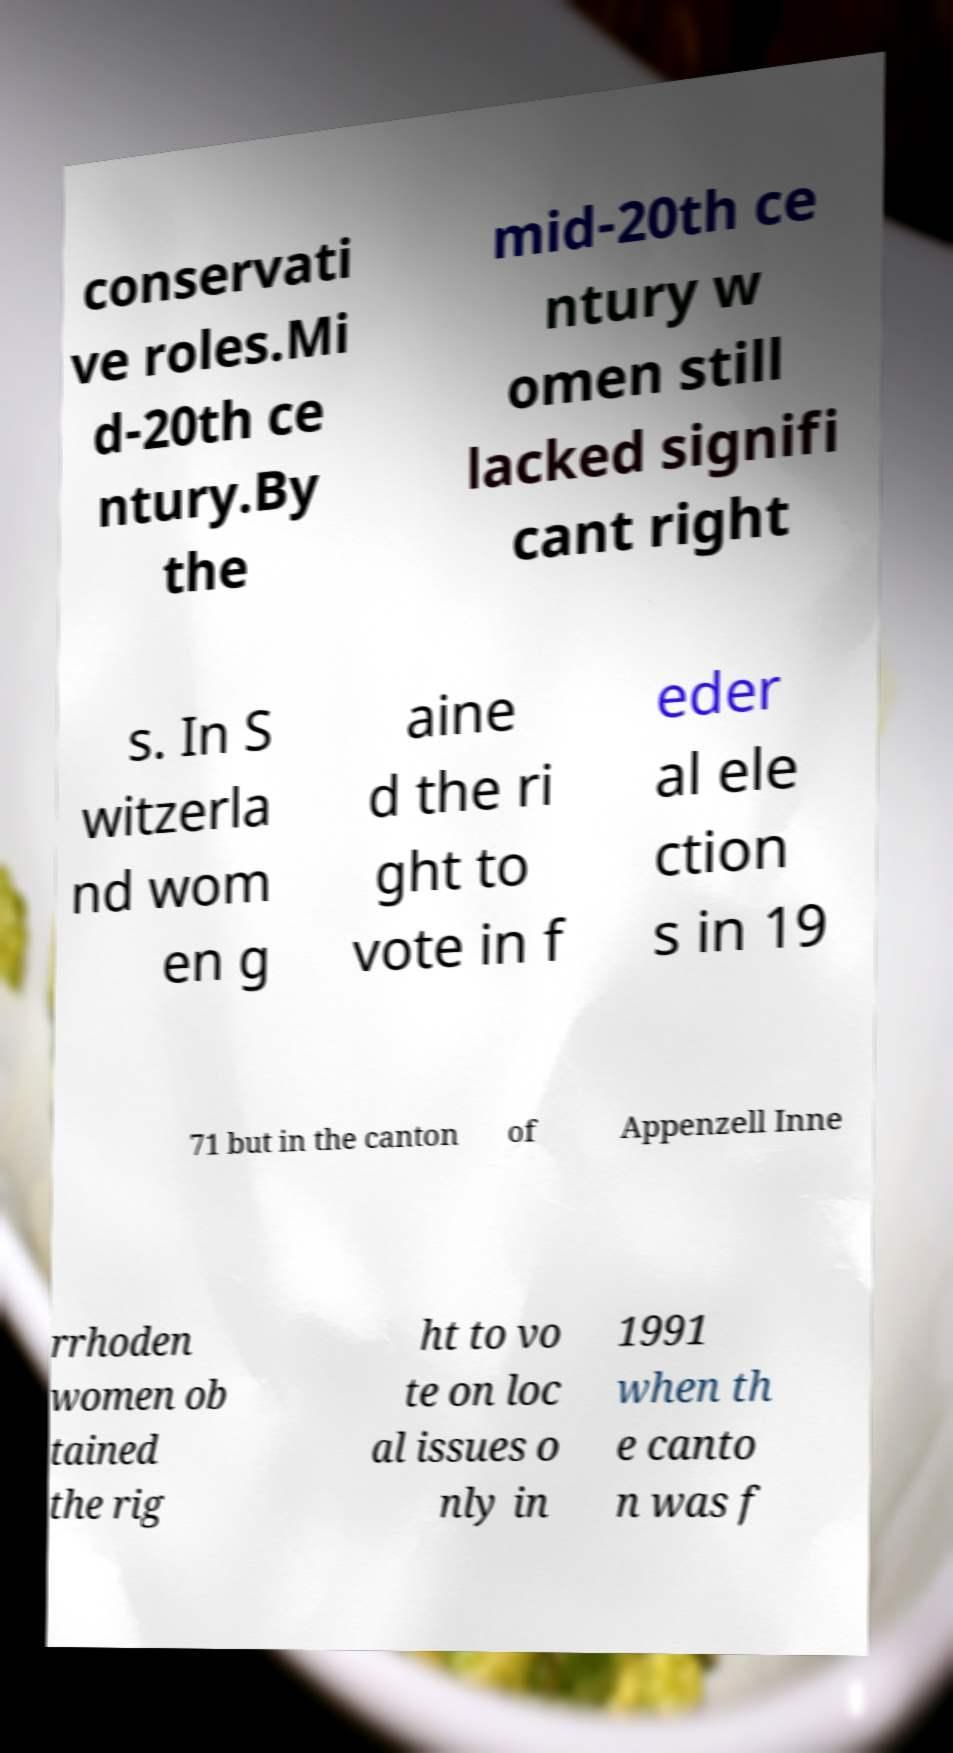What messages or text are displayed in this image? I need them in a readable, typed format. conservati ve roles.Mi d-20th ce ntury.By the mid-20th ce ntury w omen still lacked signifi cant right s. In S witzerla nd wom en g aine d the ri ght to vote in f eder al ele ction s in 19 71 but in the canton of Appenzell Inne rrhoden women ob tained the rig ht to vo te on loc al issues o nly in 1991 when th e canto n was f 